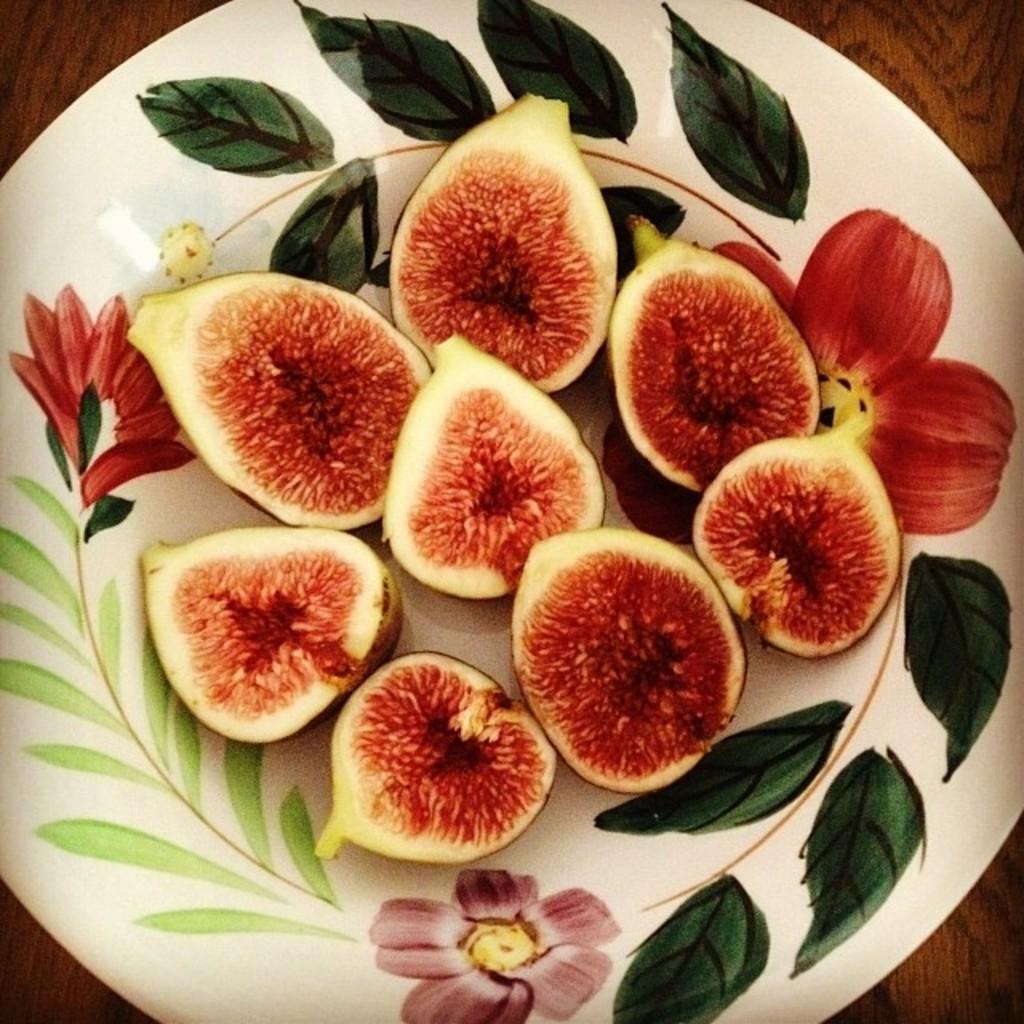Describe this image in one or two sentences. In this image we can see some pieces of figs in a plate placed on the table. 